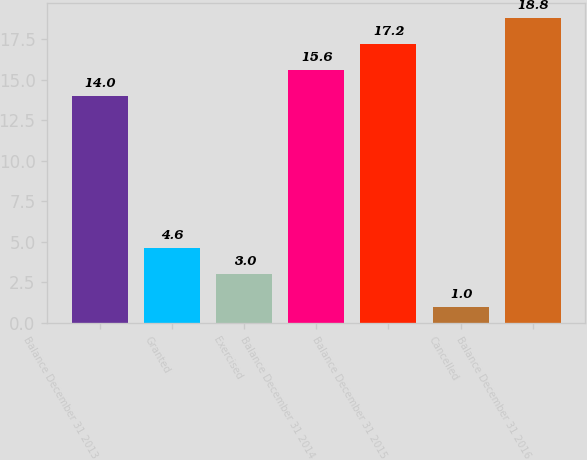Convert chart to OTSL. <chart><loc_0><loc_0><loc_500><loc_500><bar_chart><fcel>Balance December 31 2013<fcel>Granted<fcel>Exercised<fcel>Balance December 31 2014<fcel>Balance December 31 2015<fcel>Cancelled<fcel>Balance December 31 2016<nl><fcel>14<fcel>4.6<fcel>3<fcel>15.6<fcel>17.2<fcel>1<fcel>18.8<nl></chart> 